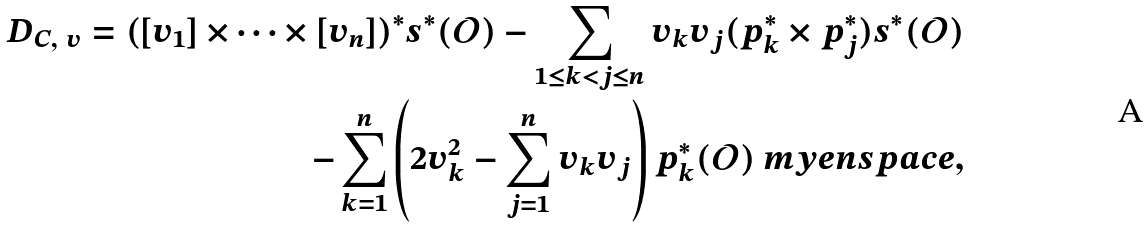Convert formula to latex. <formula><loc_0><loc_0><loc_500><loc_500>D _ { C , \ v } = ( [ v _ { 1 } ] \times \dots \times [ v _ { n } ] ) ^ { * } s ^ { * } ( \mathcal { O } ) - \sum _ { 1 \leq k < j \leq n } v _ { k } v _ { j } ( p _ { k } ^ { * } \times p _ { j } ^ { * } ) s ^ { * } ( \mathcal { O } ) \\ - \sum _ { k = 1 } ^ { n } \left ( 2 v _ { k } ^ { 2 } - \sum _ { j = 1 } ^ { n } v _ { k } v _ { j } \right ) p _ { k } ^ { * } ( \mathcal { O } ) \ m y e n s p a c e ,</formula> 